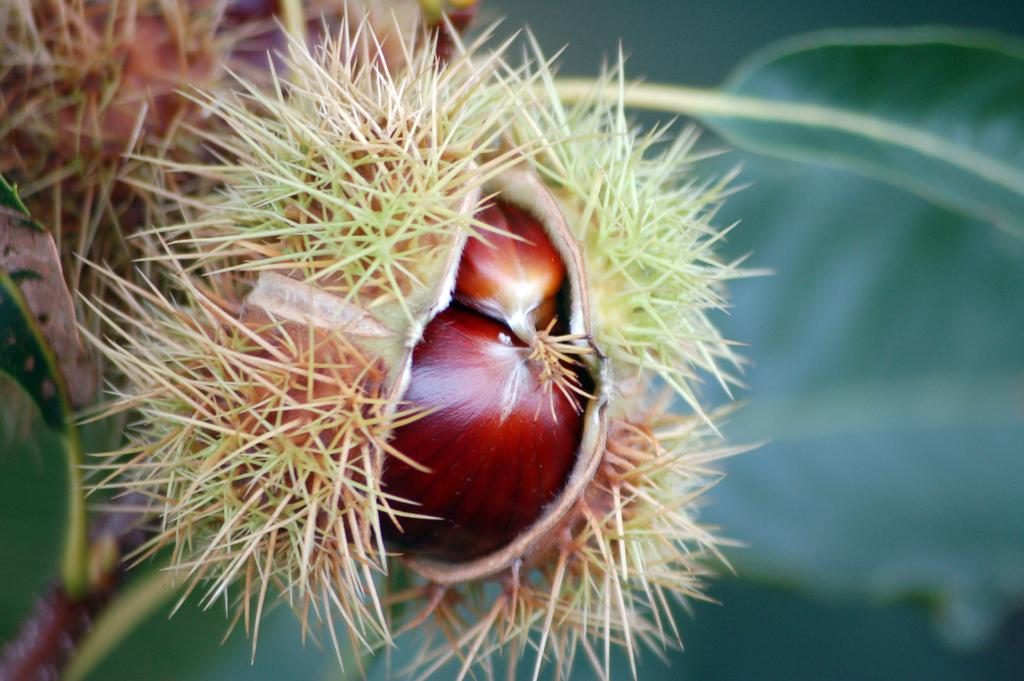What is present in the image? There is a plant in the image. What features of the plant can be observed? The plant has leaves and fruits. Can you describe the background of the image? The background of the image is blurry. What type of neck can be seen on the plant in the image? There is no neck present on the plant in the image; it is a plant, not an animal. 